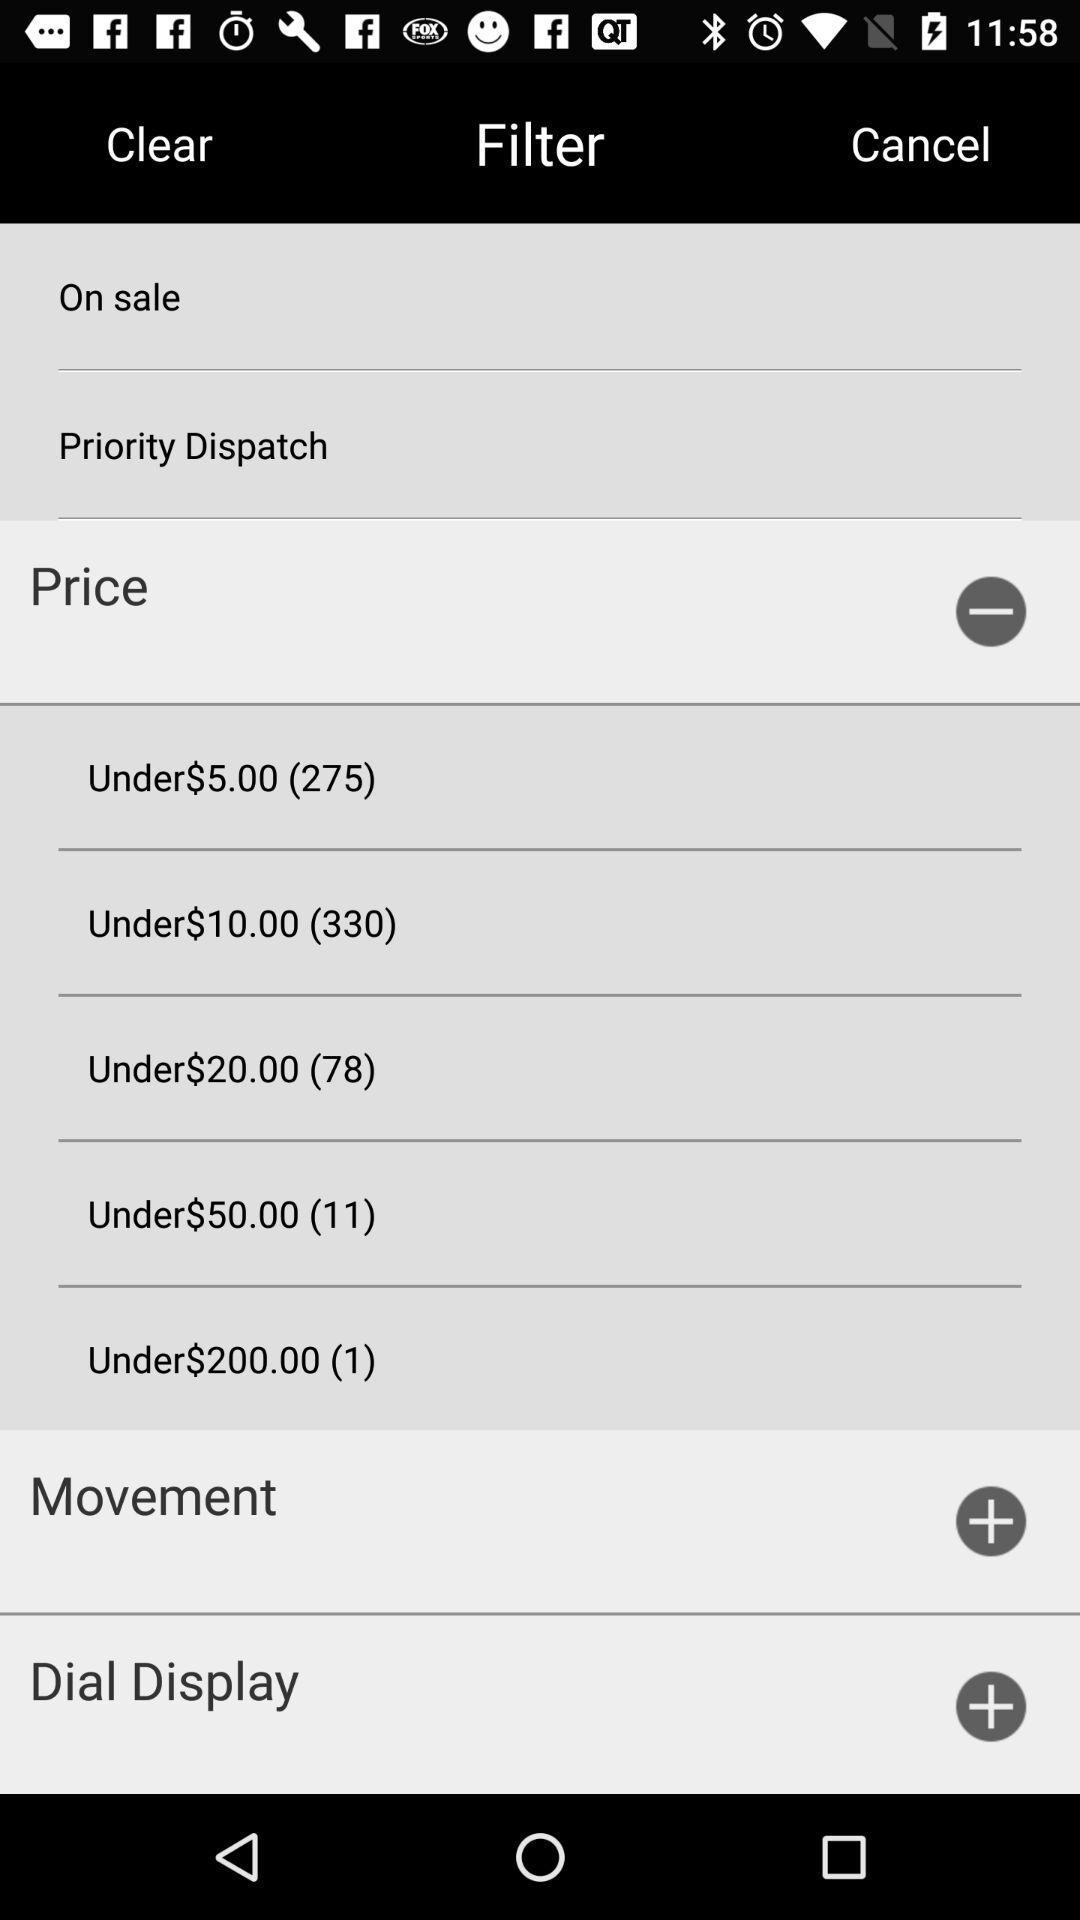How many items are under $20.00?
Answer the question using a single word or phrase. 78 